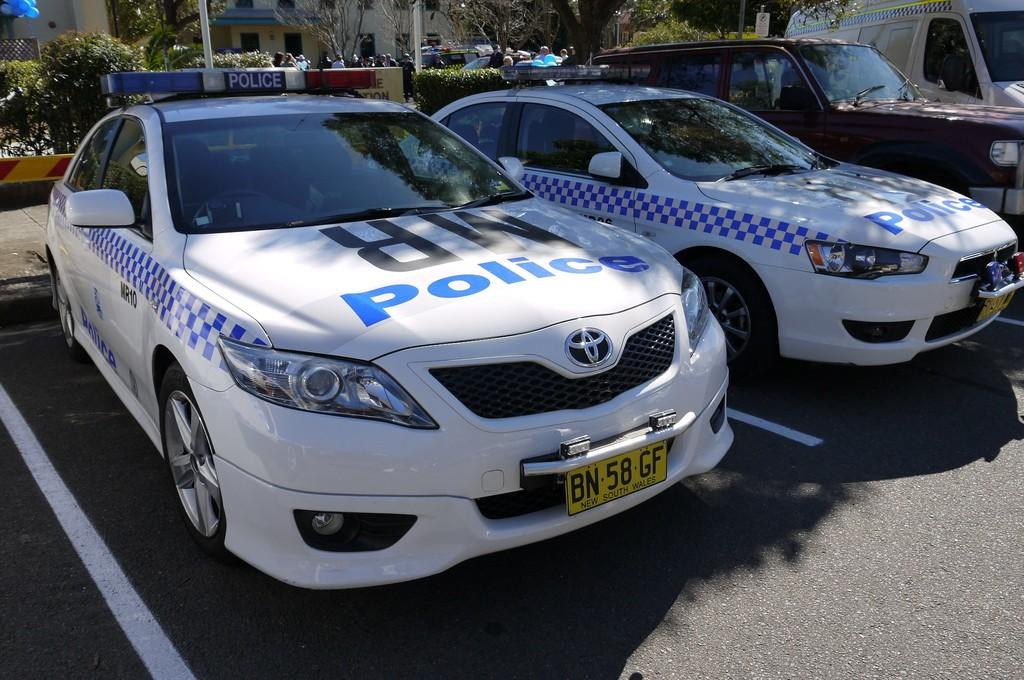What type of vehicles can be seen in the image? There are cars in the image. What other objects or living organisms are present in the image? There are plants, trees, people, and balloons in the image. How many types of vegetation are visible in the image? There are two types of vegetation visible in the image: plants and trees. What might be used for decoration or celebration in the image? Balloons are present in the image for decoration or celebration. What type of powder can be seen covering the trees in the image? There is no powder visible on the trees in the image; they appear to be their natural color. Can you see any fangs on the people in the image? There are no fangs visible on the people in the image; they have normal human teeth. 